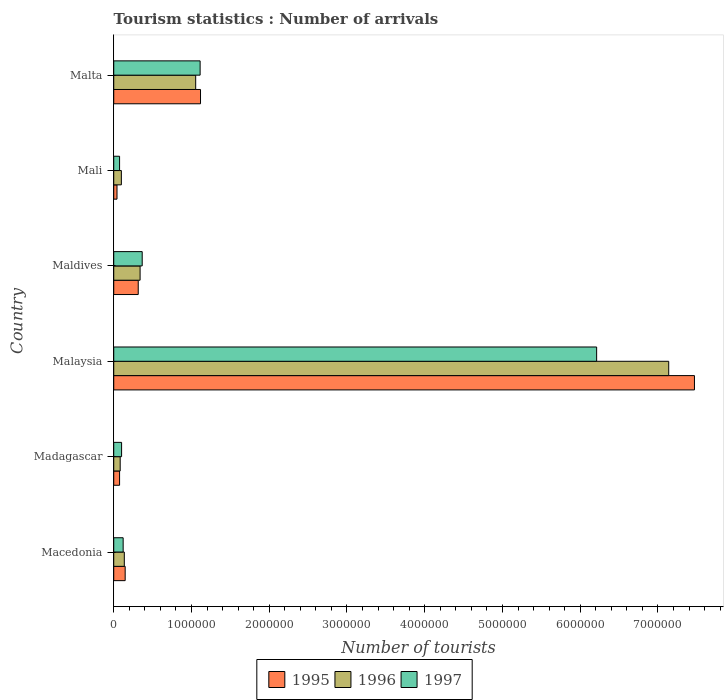How many different coloured bars are there?
Make the answer very short. 3. Are the number of bars per tick equal to the number of legend labels?
Offer a very short reply. Yes. Are the number of bars on each tick of the Y-axis equal?
Provide a short and direct response. Yes. How many bars are there on the 6th tick from the top?
Your answer should be compact. 3. What is the label of the 6th group of bars from the top?
Provide a succinct answer. Macedonia. What is the number of tourist arrivals in 1997 in Malaysia?
Provide a succinct answer. 6.21e+06. Across all countries, what is the maximum number of tourist arrivals in 1996?
Provide a succinct answer. 7.14e+06. Across all countries, what is the minimum number of tourist arrivals in 1996?
Your answer should be compact. 8.30e+04. In which country was the number of tourist arrivals in 1995 maximum?
Ensure brevity in your answer.  Malaysia. In which country was the number of tourist arrivals in 1996 minimum?
Offer a very short reply. Madagascar. What is the total number of tourist arrivals in 1996 in the graph?
Your answer should be very brief. 8.85e+06. What is the difference between the number of tourist arrivals in 1997 in Madagascar and that in Malaysia?
Your answer should be compact. -6.11e+06. What is the difference between the number of tourist arrivals in 1995 in Malta and the number of tourist arrivals in 1997 in Madagascar?
Your answer should be compact. 1.02e+06. What is the average number of tourist arrivals in 1996 per country?
Your answer should be very brief. 1.47e+06. What is the difference between the number of tourist arrivals in 1997 and number of tourist arrivals in 1996 in Malta?
Give a very brief answer. 5.70e+04. In how many countries, is the number of tourist arrivals in 1997 greater than 2000000 ?
Your response must be concise. 1. What is the ratio of the number of tourist arrivals in 1997 in Madagascar to that in Malta?
Offer a very short reply. 0.09. What is the difference between the highest and the second highest number of tourist arrivals in 1997?
Keep it short and to the point. 5.10e+06. What is the difference between the highest and the lowest number of tourist arrivals in 1995?
Ensure brevity in your answer.  7.43e+06. Is the sum of the number of tourist arrivals in 1995 in Maldives and Malta greater than the maximum number of tourist arrivals in 1996 across all countries?
Your response must be concise. No. What does the 3rd bar from the top in Maldives represents?
Give a very brief answer. 1995. What does the 2nd bar from the bottom in Malaysia represents?
Offer a terse response. 1996. Is it the case that in every country, the sum of the number of tourist arrivals in 1996 and number of tourist arrivals in 1995 is greater than the number of tourist arrivals in 1997?
Your response must be concise. Yes. How many bars are there?
Offer a very short reply. 18. How many countries are there in the graph?
Provide a short and direct response. 6. How many legend labels are there?
Make the answer very short. 3. What is the title of the graph?
Your answer should be compact. Tourism statistics : Number of arrivals. Does "1966" appear as one of the legend labels in the graph?
Your answer should be very brief. No. What is the label or title of the X-axis?
Offer a terse response. Number of tourists. What is the Number of tourists of 1995 in Macedonia?
Your answer should be very brief. 1.47e+05. What is the Number of tourists of 1996 in Macedonia?
Your response must be concise. 1.36e+05. What is the Number of tourists of 1997 in Macedonia?
Give a very brief answer. 1.21e+05. What is the Number of tourists in 1995 in Madagascar?
Make the answer very short. 7.50e+04. What is the Number of tourists of 1996 in Madagascar?
Provide a short and direct response. 8.30e+04. What is the Number of tourists of 1997 in Madagascar?
Make the answer very short. 1.01e+05. What is the Number of tourists in 1995 in Malaysia?
Offer a terse response. 7.47e+06. What is the Number of tourists of 1996 in Malaysia?
Provide a succinct answer. 7.14e+06. What is the Number of tourists of 1997 in Malaysia?
Offer a very short reply. 6.21e+06. What is the Number of tourists in 1995 in Maldives?
Offer a terse response. 3.15e+05. What is the Number of tourists of 1996 in Maldives?
Your answer should be compact. 3.39e+05. What is the Number of tourists of 1997 in Maldives?
Provide a short and direct response. 3.66e+05. What is the Number of tourists of 1995 in Mali?
Provide a short and direct response. 4.20e+04. What is the Number of tourists of 1996 in Mali?
Provide a short and direct response. 9.80e+04. What is the Number of tourists in 1997 in Mali?
Provide a short and direct response. 7.50e+04. What is the Number of tourists of 1995 in Malta?
Provide a succinct answer. 1.12e+06. What is the Number of tourists in 1996 in Malta?
Your answer should be very brief. 1.05e+06. What is the Number of tourists of 1997 in Malta?
Make the answer very short. 1.11e+06. Across all countries, what is the maximum Number of tourists of 1995?
Ensure brevity in your answer.  7.47e+06. Across all countries, what is the maximum Number of tourists of 1996?
Offer a terse response. 7.14e+06. Across all countries, what is the maximum Number of tourists in 1997?
Provide a succinct answer. 6.21e+06. Across all countries, what is the minimum Number of tourists in 1995?
Offer a terse response. 4.20e+04. Across all countries, what is the minimum Number of tourists of 1996?
Ensure brevity in your answer.  8.30e+04. Across all countries, what is the minimum Number of tourists of 1997?
Your answer should be very brief. 7.50e+04. What is the total Number of tourists of 1995 in the graph?
Offer a very short reply. 9.16e+06. What is the total Number of tourists in 1996 in the graph?
Provide a short and direct response. 8.85e+06. What is the total Number of tourists in 1997 in the graph?
Offer a terse response. 7.98e+06. What is the difference between the Number of tourists in 1995 in Macedonia and that in Madagascar?
Ensure brevity in your answer.  7.20e+04. What is the difference between the Number of tourists in 1996 in Macedonia and that in Madagascar?
Provide a succinct answer. 5.30e+04. What is the difference between the Number of tourists in 1997 in Macedonia and that in Madagascar?
Keep it short and to the point. 2.00e+04. What is the difference between the Number of tourists of 1995 in Macedonia and that in Malaysia?
Keep it short and to the point. -7.32e+06. What is the difference between the Number of tourists in 1996 in Macedonia and that in Malaysia?
Make the answer very short. -7.00e+06. What is the difference between the Number of tourists of 1997 in Macedonia and that in Malaysia?
Your response must be concise. -6.09e+06. What is the difference between the Number of tourists of 1995 in Macedonia and that in Maldives?
Ensure brevity in your answer.  -1.68e+05. What is the difference between the Number of tourists in 1996 in Macedonia and that in Maldives?
Offer a terse response. -2.03e+05. What is the difference between the Number of tourists in 1997 in Macedonia and that in Maldives?
Provide a short and direct response. -2.45e+05. What is the difference between the Number of tourists in 1995 in Macedonia and that in Mali?
Ensure brevity in your answer.  1.05e+05. What is the difference between the Number of tourists in 1996 in Macedonia and that in Mali?
Offer a terse response. 3.80e+04. What is the difference between the Number of tourists in 1997 in Macedonia and that in Mali?
Offer a very short reply. 4.60e+04. What is the difference between the Number of tourists in 1995 in Macedonia and that in Malta?
Your answer should be compact. -9.69e+05. What is the difference between the Number of tourists in 1996 in Macedonia and that in Malta?
Keep it short and to the point. -9.18e+05. What is the difference between the Number of tourists in 1997 in Macedonia and that in Malta?
Offer a terse response. -9.90e+05. What is the difference between the Number of tourists of 1995 in Madagascar and that in Malaysia?
Keep it short and to the point. -7.39e+06. What is the difference between the Number of tourists in 1996 in Madagascar and that in Malaysia?
Give a very brief answer. -7.06e+06. What is the difference between the Number of tourists of 1997 in Madagascar and that in Malaysia?
Give a very brief answer. -6.11e+06. What is the difference between the Number of tourists in 1996 in Madagascar and that in Maldives?
Offer a terse response. -2.56e+05. What is the difference between the Number of tourists in 1997 in Madagascar and that in Maldives?
Give a very brief answer. -2.65e+05. What is the difference between the Number of tourists of 1995 in Madagascar and that in Mali?
Make the answer very short. 3.30e+04. What is the difference between the Number of tourists in 1996 in Madagascar and that in Mali?
Offer a very short reply. -1.50e+04. What is the difference between the Number of tourists of 1997 in Madagascar and that in Mali?
Keep it short and to the point. 2.60e+04. What is the difference between the Number of tourists of 1995 in Madagascar and that in Malta?
Your answer should be very brief. -1.04e+06. What is the difference between the Number of tourists in 1996 in Madagascar and that in Malta?
Make the answer very short. -9.71e+05. What is the difference between the Number of tourists in 1997 in Madagascar and that in Malta?
Make the answer very short. -1.01e+06. What is the difference between the Number of tourists of 1995 in Malaysia and that in Maldives?
Ensure brevity in your answer.  7.15e+06. What is the difference between the Number of tourists in 1996 in Malaysia and that in Maldives?
Offer a very short reply. 6.80e+06. What is the difference between the Number of tourists in 1997 in Malaysia and that in Maldives?
Ensure brevity in your answer.  5.84e+06. What is the difference between the Number of tourists of 1995 in Malaysia and that in Mali?
Your response must be concise. 7.43e+06. What is the difference between the Number of tourists of 1996 in Malaysia and that in Mali?
Give a very brief answer. 7.04e+06. What is the difference between the Number of tourists in 1997 in Malaysia and that in Mali?
Offer a terse response. 6.14e+06. What is the difference between the Number of tourists of 1995 in Malaysia and that in Malta?
Offer a very short reply. 6.35e+06. What is the difference between the Number of tourists of 1996 in Malaysia and that in Malta?
Make the answer very short. 6.08e+06. What is the difference between the Number of tourists in 1997 in Malaysia and that in Malta?
Provide a succinct answer. 5.10e+06. What is the difference between the Number of tourists in 1995 in Maldives and that in Mali?
Ensure brevity in your answer.  2.73e+05. What is the difference between the Number of tourists of 1996 in Maldives and that in Mali?
Your answer should be compact. 2.41e+05. What is the difference between the Number of tourists in 1997 in Maldives and that in Mali?
Your answer should be compact. 2.91e+05. What is the difference between the Number of tourists of 1995 in Maldives and that in Malta?
Your response must be concise. -8.01e+05. What is the difference between the Number of tourists of 1996 in Maldives and that in Malta?
Your answer should be compact. -7.15e+05. What is the difference between the Number of tourists in 1997 in Maldives and that in Malta?
Provide a succinct answer. -7.45e+05. What is the difference between the Number of tourists in 1995 in Mali and that in Malta?
Offer a terse response. -1.07e+06. What is the difference between the Number of tourists in 1996 in Mali and that in Malta?
Provide a short and direct response. -9.56e+05. What is the difference between the Number of tourists in 1997 in Mali and that in Malta?
Ensure brevity in your answer.  -1.04e+06. What is the difference between the Number of tourists of 1995 in Macedonia and the Number of tourists of 1996 in Madagascar?
Ensure brevity in your answer.  6.40e+04. What is the difference between the Number of tourists of 1995 in Macedonia and the Number of tourists of 1997 in Madagascar?
Give a very brief answer. 4.60e+04. What is the difference between the Number of tourists of 1996 in Macedonia and the Number of tourists of 1997 in Madagascar?
Provide a short and direct response. 3.50e+04. What is the difference between the Number of tourists in 1995 in Macedonia and the Number of tourists in 1996 in Malaysia?
Ensure brevity in your answer.  -6.99e+06. What is the difference between the Number of tourists in 1995 in Macedonia and the Number of tourists in 1997 in Malaysia?
Make the answer very short. -6.06e+06. What is the difference between the Number of tourists in 1996 in Macedonia and the Number of tourists in 1997 in Malaysia?
Give a very brief answer. -6.08e+06. What is the difference between the Number of tourists in 1995 in Macedonia and the Number of tourists in 1996 in Maldives?
Your answer should be compact. -1.92e+05. What is the difference between the Number of tourists in 1995 in Macedonia and the Number of tourists in 1997 in Maldives?
Your answer should be compact. -2.19e+05. What is the difference between the Number of tourists in 1996 in Macedonia and the Number of tourists in 1997 in Maldives?
Provide a succinct answer. -2.30e+05. What is the difference between the Number of tourists of 1995 in Macedonia and the Number of tourists of 1996 in Mali?
Ensure brevity in your answer.  4.90e+04. What is the difference between the Number of tourists of 1995 in Macedonia and the Number of tourists of 1997 in Mali?
Your answer should be very brief. 7.20e+04. What is the difference between the Number of tourists in 1996 in Macedonia and the Number of tourists in 1997 in Mali?
Make the answer very short. 6.10e+04. What is the difference between the Number of tourists in 1995 in Macedonia and the Number of tourists in 1996 in Malta?
Your response must be concise. -9.07e+05. What is the difference between the Number of tourists of 1995 in Macedonia and the Number of tourists of 1997 in Malta?
Your response must be concise. -9.64e+05. What is the difference between the Number of tourists of 1996 in Macedonia and the Number of tourists of 1997 in Malta?
Your response must be concise. -9.75e+05. What is the difference between the Number of tourists of 1995 in Madagascar and the Number of tourists of 1996 in Malaysia?
Your response must be concise. -7.06e+06. What is the difference between the Number of tourists of 1995 in Madagascar and the Number of tourists of 1997 in Malaysia?
Provide a short and direct response. -6.14e+06. What is the difference between the Number of tourists in 1996 in Madagascar and the Number of tourists in 1997 in Malaysia?
Your response must be concise. -6.13e+06. What is the difference between the Number of tourists in 1995 in Madagascar and the Number of tourists in 1996 in Maldives?
Keep it short and to the point. -2.64e+05. What is the difference between the Number of tourists in 1995 in Madagascar and the Number of tourists in 1997 in Maldives?
Give a very brief answer. -2.91e+05. What is the difference between the Number of tourists in 1996 in Madagascar and the Number of tourists in 1997 in Maldives?
Offer a terse response. -2.83e+05. What is the difference between the Number of tourists in 1995 in Madagascar and the Number of tourists in 1996 in Mali?
Your answer should be compact. -2.30e+04. What is the difference between the Number of tourists of 1995 in Madagascar and the Number of tourists of 1997 in Mali?
Make the answer very short. 0. What is the difference between the Number of tourists in 1996 in Madagascar and the Number of tourists in 1997 in Mali?
Ensure brevity in your answer.  8000. What is the difference between the Number of tourists in 1995 in Madagascar and the Number of tourists in 1996 in Malta?
Your response must be concise. -9.79e+05. What is the difference between the Number of tourists in 1995 in Madagascar and the Number of tourists in 1997 in Malta?
Provide a short and direct response. -1.04e+06. What is the difference between the Number of tourists in 1996 in Madagascar and the Number of tourists in 1997 in Malta?
Provide a short and direct response. -1.03e+06. What is the difference between the Number of tourists of 1995 in Malaysia and the Number of tourists of 1996 in Maldives?
Your answer should be compact. 7.13e+06. What is the difference between the Number of tourists of 1995 in Malaysia and the Number of tourists of 1997 in Maldives?
Keep it short and to the point. 7.10e+06. What is the difference between the Number of tourists in 1996 in Malaysia and the Number of tourists in 1997 in Maldives?
Keep it short and to the point. 6.77e+06. What is the difference between the Number of tourists in 1995 in Malaysia and the Number of tourists in 1996 in Mali?
Keep it short and to the point. 7.37e+06. What is the difference between the Number of tourists in 1995 in Malaysia and the Number of tourists in 1997 in Mali?
Provide a succinct answer. 7.39e+06. What is the difference between the Number of tourists of 1996 in Malaysia and the Number of tourists of 1997 in Mali?
Keep it short and to the point. 7.06e+06. What is the difference between the Number of tourists of 1995 in Malaysia and the Number of tourists of 1996 in Malta?
Offer a very short reply. 6.42e+06. What is the difference between the Number of tourists of 1995 in Malaysia and the Number of tourists of 1997 in Malta?
Provide a short and direct response. 6.36e+06. What is the difference between the Number of tourists in 1996 in Malaysia and the Number of tourists in 1997 in Malta?
Your answer should be very brief. 6.03e+06. What is the difference between the Number of tourists of 1995 in Maldives and the Number of tourists of 1996 in Mali?
Give a very brief answer. 2.17e+05. What is the difference between the Number of tourists in 1996 in Maldives and the Number of tourists in 1997 in Mali?
Give a very brief answer. 2.64e+05. What is the difference between the Number of tourists in 1995 in Maldives and the Number of tourists in 1996 in Malta?
Provide a short and direct response. -7.39e+05. What is the difference between the Number of tourists in 1995 in Maldives and the Number of tourists in 1997 in Malta?
Offer a very short reply. -7.96e+05. What is the difference between the Number of tourists of 1996 in Maldives and the Number of tourists of 1997 in Malta?
Keep it short and to the point. -7.72e+05. What is the difference between the Number of tourists in 1995 in Mali and the Number of tourists in 1996 in Malta?
Give a very brief answer. -1.01e+06. What is the difference between the Number of tourists in 1995 in Mali and the Number of tourists in 1997 in Malta?
Give a very brief answer. -1.07e+06. What is the difference between the Number of tourists in 1996 in Mali and the Number of tourists in 1997 in Malta?
Offer a very short reply. -1.01e+06. What is the average Number of tourists of 1995 per country?
Offer a terse response. 1.53e+06. What is the average Number of tourists in 1996 per country?
Your answer should be very brief. 1.47e+06. What is the average Number of tourists in 1997 per country?
Provide a succinct answer. 1.33e+06. What is the difference between the Number of tourists in 1995 and Number of tourists in 1996 in Macedonia?
Your answer should be very brief. 1.10e+04. What is the difference between the Number of tourists in 1995 and Number of tourists in 1997 in Macedonia?
Keep it short and to the point. 2.60e+04. What is the difference between the Number of tourists in 1996 and Number of tourists in 1997 in Macedonia?
Ensure brevity in your answer.  1.50e+04. What is the difference between the Number of tourists of 1995 and Number of tourists of 1996 in Madagascar?
Your answer should be compact. -8000. What is the difference between the Number of tourists of 1995 and Number of tourists of 1997 in Madagascar?
Provide a short and direct response. -2.60e+04. What is the difference between the Number of tourists of 1996 and Number of tourists of 1997 in Madagascar?
Your answer should be very brief. -1.80e+04. What is the difference between the Number of tourists in 1995 and Number of tourists in 1996 in Malaysia?
Your answer should be compact. 3.31e+05. What is the difference between the Number of tourists in 1995 and Number of tourists in 1997 in Malaysia?
Keep it short and to the point. 1.26e+06. What is the difference between the Number of tourists of 1996 and Number of tourists of 1997 in Malaysia?
Keep it short and to the point. 9.27e+05. What is the difference between the Number of tourists of 1995 and Number of tourists of 1996 in Maldives?
Your response must be concise. -2.40e+04. What is the difference between the Number of tourists of 1995 and Number of tourists of 1997 in Maldives?
Your response must be concise. -5.10e+04. What is the difference between the Number of tourists of 1996 and Number of tourists of 1997 in Maldives?
Provide a succinct answer. -2.70e+04. What is the difference between the Number of tourists of 1995 and Number of tourists of 1996 in Mali?
Give a very brief answer. -5.60e+04. What is the difference between the Number of tourists in 1995 and Number of tourists in 1997 in Mali?
Make the answer very short. -3.30e+04. What is the difference between the Number of tourists in 1996 and Number of tourists in 1997 in Mali?
Offer a very short reply. 2.30e+04. What is the difference between the Number of tourists in 1995 and Number of tourists in 1996 in Malta?
Offer a very short reply. 6.20e+04. What is the difference between the Number of tourists of 1995 and Number of tourists of 1997 in Malta?
Ensure brevity in your answer.  5000. What is the difference between the Number of tourists of 1996 and Number of tourists of 1997 in Malta?
Offer a very short reply. -5.70e+04. What is the ratio of the Number of tourists of 1995 in Macedonia to that in Madagascar?
Make the answer very short. 1.96. What is the ratio of the Number of tourists in 1996 in Macedonia to that in Madagascar?
Give a very brief answer. 1.64. What is the ratio of the Number of tourists in 1997 in Macedonia to that in Madagascar?
Provide a short and direct response. 1.2. What is the ratio of the Number of tourists of 1995 in Macedonia to that in Malaysia?
Keep it short and to the point. 0.02. What is the ratio of the Number of tourists in 1996 in Macedonia to that in Malaysia?
Your response must be concise. 0.02. What is the ratio of the Number of tourists of 1997 in Macedonia to that in Malaysia?
Ensure brevity in your answer.  0.02. What is the ratio of the Number of tourists of 1995 in Macedonia to that in Maldives?
Offer a terse response. 0.47. What is the ratio of the Number of tourists in 1996 in Macedonia to that in Maldives?
Your answer should be compact. 0.4. What is the ratio of the Number of tourists in 1997 in Macedonia to that in Maldives?
Your answer should be compact. 0.33. What is the ratio of the Number of tourists of 1996 in Macedonia to that in Mali?
Ensure brevity in your answer.  1.39. What is the ratio of the Number of tourists in 1997 in Macedonia to that in Mali?
Offer a terse response. 1.61. What is the ratio of the Number of tourists in 1995 in Macedonia to that in Malta?
Offer a very short reply. 0.13. What is the ratio of the Number of tourists in 1996 in Macedonia to that in Malta?
Offer a very short reply. 0.13. What is the ratio of the Number of tourists in 1997 in Macedonia to that in Malta?
Offer a very short reply. 0.11. What is the ratio of the Number of tourists in 1995 in Madagascar to that in Malaysia?
Your answer should be compact. 0.01. What is the ratio of the Number of tourists of 1996 in Madagascar to that in Malaysia?
Make the answer very short. 0.01. What is the ratio of the Number of tourists in 1997 in Madagascar to that in Malaysia?
Keep it short and to the point. 0.02. What is the ratio of the Number of tourists of 1995 in Madagascar to that in Maldives?
Offer a very short reply. 0.24. What is the ratio of the Number of tourists in 1996 in Madagascar to that in Maldives?
Make the answer very short. 0.24. What is the ratio of the Number of tourists in 1997 in Madagascar to that in Maldives?
Offer a terse response. 0.28. What is the ratio of the Number of tourists in 1995 in Madagascar to that in Mali?
Your response must be concise. 1.79. What is the ratio of the Number of tourists in 1996 in Madagascar to that in Mali?
Keep it short and to the point. 0.85. What is the ratio of the Number of tourists of 1997 in Madagascar to that in Mali?
Your response must be concise. 1.35. What is the ratio of the Number of tourists of 1995 in Madagascar to that in Malta?
Make the answer very short. 0.07. What is the ratio of the Number of tourists of 1996 in Madagascar to that in Malta?
Your answer should be compact. 0.08. What is the ratio of the Number of tourists of 1997 in Madagascar to that in Malta?
Offer a terse response. 0.09. What is the ratio of the Number of tourists of 1995 in Malaysia to that in Maldives?
Keep it short and to the point. 23.71. What is the ratio of the Number of tourists in 1996 in Malaysia to that in Maldives?
Provide a succinct answer. 21.06. What is the ratio of the Number of tourists in 1997 in Malaysia to that in Maldives?
Offer a terse response. 16.97. What is the ratio of the Number of tourists of 1995 in Malaysia to that in Mali?
Your answer should be very brief. 177.83. What is the ratio of the Number of tourists of 1996 in Malaysia to that in Mali?
Give a very brief answer. 72.84. What is the ratio of the Number of tourists of 1997 in Malaysia to that in Mali?
Ensure brevity in your answer.  82.81. What is the ratio of the Number of tourists in 1995 in Malaysia to that in Malta?
Offer a terse response. 6.69. What is the ratio of the Number of tourists in 1996 in Malaysia to that in Malta?
Offer a very short reply. 6.77. What is the ratio of the Number of tourists in 1997 in Malaysia to that in Malta?
Your answer should be very brief. 5.59. What is the ratio of the Number of tourists of 1995 in Maldives to that in Mali?
Ensure brevity in your answer.  7.5. What is the ratio of the Number of tourists in 1996 in Maldives to that in Mali?
Your answer should be very brief. 3.46. What is the ratio of the Number of tourists in 1997 in Maldives to that in Mali?
Provide a succinct answer. 4.88. What is the ratio of the Number of tourists in 1995 in Maldives to that in Malta?
Ensure brevity in your answer.  0.28. What is the ratio of the Number of tourists in 1996 in Maldives to that in Malta?
Keep it short and to the point. 0.32. What is the ratio of the Number of tourists in 1997 in Maldives to that in Malta?
Your response must be concise. 0.33. What is the ratio of the Number of tourists in 1995 in Mali to that in Malta?
Your response must be concise. 0.04. What is the ratio of the Number of tourists of 1996 in Mali to that in Malta?
Your answer should be very brief. 0.09. What is the ratio of the Number of tourists in 1997 in Mali to that in Malta?
Provide a short and direct response. 0.07. What is the difference between the highest and the second highest Number of tourists in 1995?
Ensure brevity in your answer.  6.35e+06. What is the difference between the highest and the second highest Number of tourists of 1996?
Your response must be concise. 6.08e+06. What is the difference between the highest and the second highest Number of tourists in 1997?
Make the answer very short. 5.10e+06. What is the difference between the highest and the lowest Number of tourists in 1995?
Offer a very short reply. 7.43e+06. What is the difference between the highest and the lowest Number of tourists of 1996?
Provide a succinct answer. 7.06e+06. What is the difference between the highest and the lowest Number of tourists in 1997?
Keep it short and to the point. 6.14e+06. 